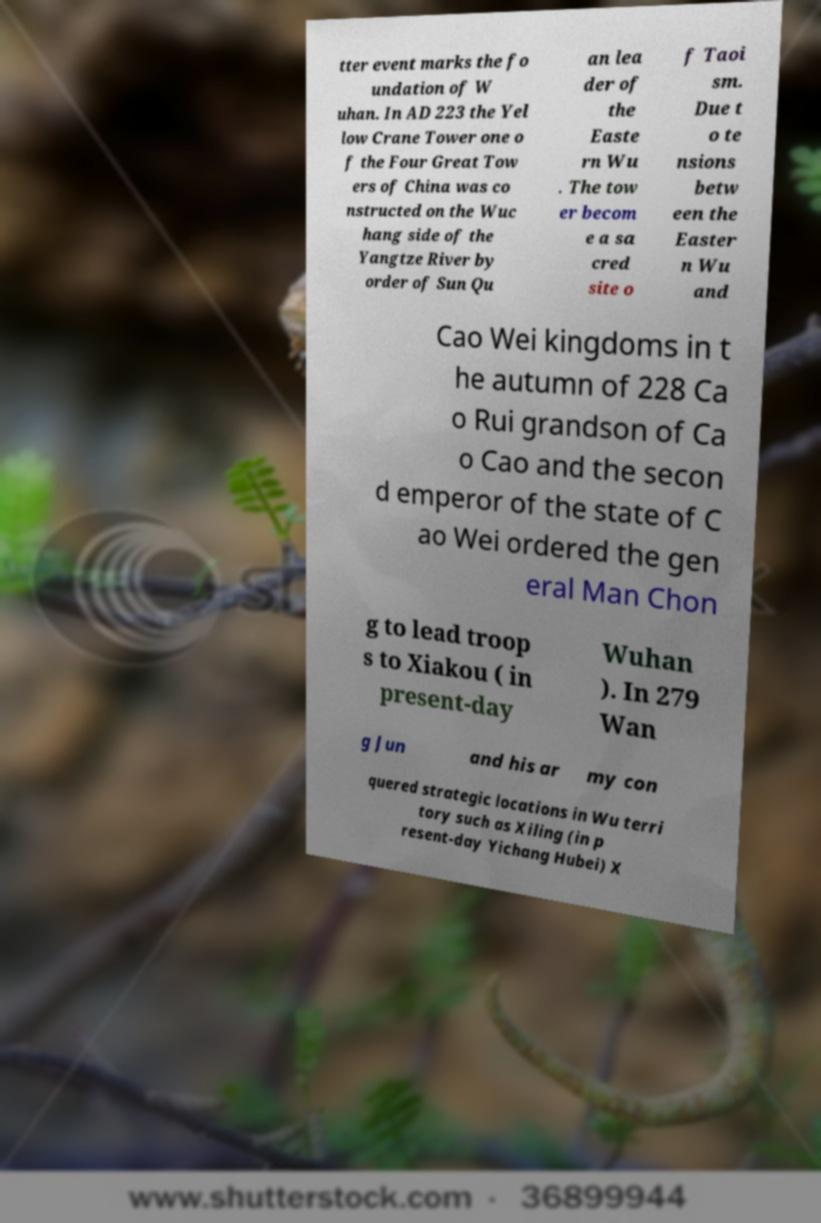For documentation purposes, I need the text within this image transcribed. Could you provide that? tter event marks the fo undation of W uhan. In AD 223 the Yel low Crane Tower one o f the Four Great Tow ers of China was co nstructed on the Wuc hang side of the Yangtze River by order of Sun Qu an lea der of the Easte rn Wu . The tow er becom e a sa cred site o f Taoi sm. Due t o te nsions betw een the Easter n Wu and Cao Wei kingdoms in t he autumn of 228 Ca o Rui grandson of Ca o Cao and the secon d emperor of the state of C ao Wei ordered the gen eral Man Chon g to lead troop s to Xiakou ( in present-day Wuhan ). In 279 Wan g Jun and his ar my con quered strategic locations in Wu terri tory such as Xiling (in p resent-day Yichang Hubei) X 